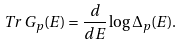Convert formula to latex. <formula><loc_0><loc_0><loc_500><loc_500>T r \, G _ { p } ( E ) = \frac { d } { d E } \log \Delta _ { p } ( E ) .</formula> 